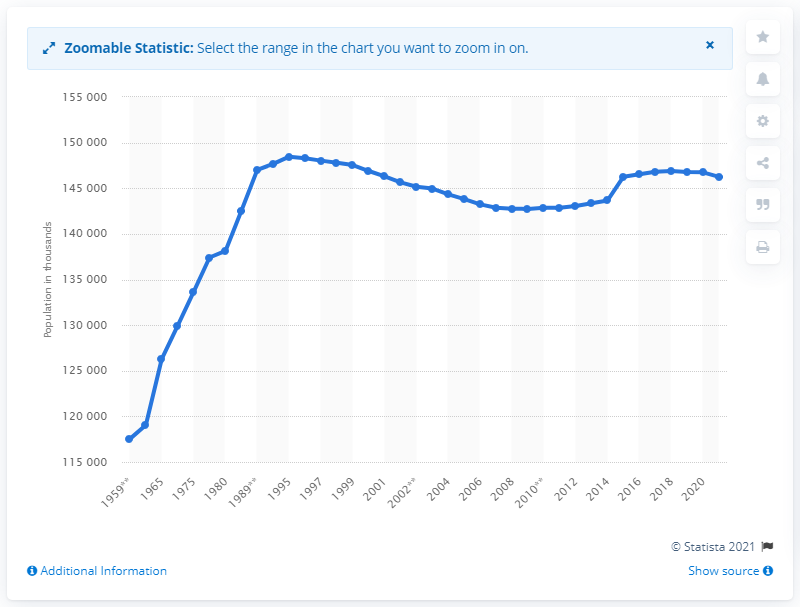Highlight a few significant elements in this photo. In 2009, the population increased. In 1995, the population of Russia stopped growing. 